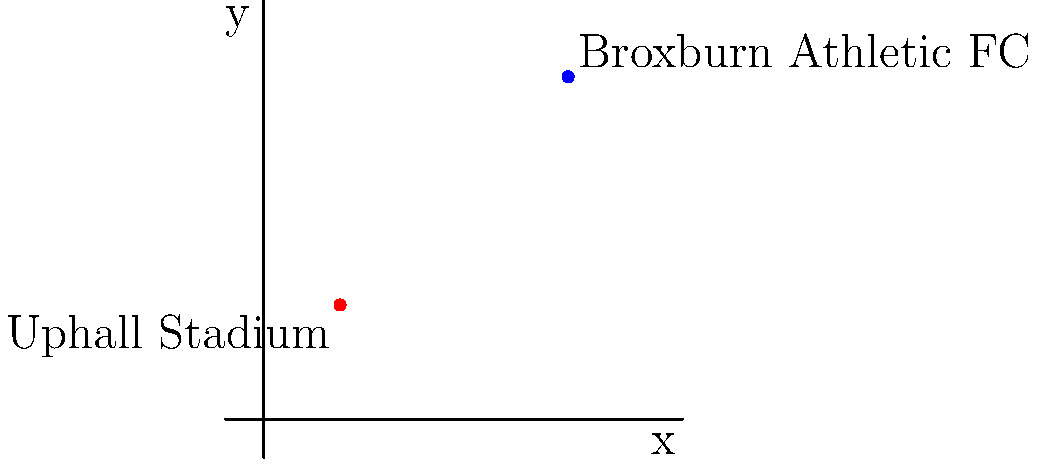The Uphall Stadium, a historical football landmark, is located at coordinates (2, 3) on the town map. A newer football facility, Broxburn Athletic FC, is situated at (8, 9). Using the distance formula, calculate the straight-line distance between these two significant football landmarks. Round your answer to the nearest tenth of a unit. To find the distance between two points, we use the distance formula:

$$ d = \sqrt{(x_2 - x_1)^2 + (y_2 - y_1)^2} $$

Where $(x_1, y_1)$ is the first point and $(x_2, y_2)$ is the second point.

Step 1: Identify the coordinates
- Uphall Stadium: $(x_1, y_1) = (2, 3)$
- Broxburn Athletic FC: $(x_2, y_2) = (8, 9)$

Step 2: Substitute these values into the formula
$$ d = \sqrt{(8 - 2)^2 + (9 - 3)^2} $$

Step 3: Simplify inside the parentheses
$$ d = \sqrt{6^2 + 6^2} $$

Step 4: Calculate the squares
$$ d = \sqrt{36 + 36} $$

Step 5: Add under the square root
$$ d = \sqrt{72} $$

Step 6: Simplify the square root
$$ d = 6\sqrt{2} \approx 8.485 $$

Step 7: Round to the nearest tenth
$$ d \approx 8.5 $$

Therefore, the distance between Uphall Stadium and Broxburn Athletic FC is approximately 8.5 units.
Answer: 8.5 units 